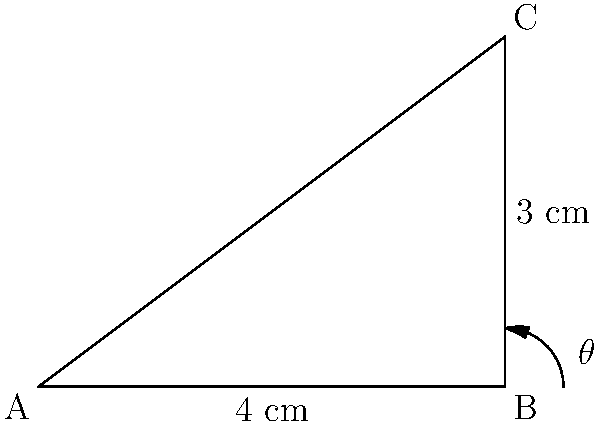A makeup artist is designing an ergonomic brush handle for optimal application. The handle forms a right-angled triangle with the brush head, where the handle length is 4 cm and the brush head height is 3 cm. What is the angle $\theta$ between the handle and the horizontal surface for optimal application? To find the angle $\theta$, we can use the trigonometric function tangent (tan). In a right-angled triangle:

1. tan(θ) = opposite side / adjacent side
2. In this case, the opposite side is the brush head height (3 cm), and the adjacent side is the handle length (4 cm).
3. So, we have: tan(θ) = 3/4
4. To find θ, we need to use the inverse tangent (arctan or tan^(-1)):
   θ = arctan(3/4)
5. Using a calculator or mathematical software:
   θ ≈ 36.87°

Therefore, the angle between the handle and the horizontal surface for optimal application is approximately 36.87°.
Answer: $\theta \approx 36.87°$ 